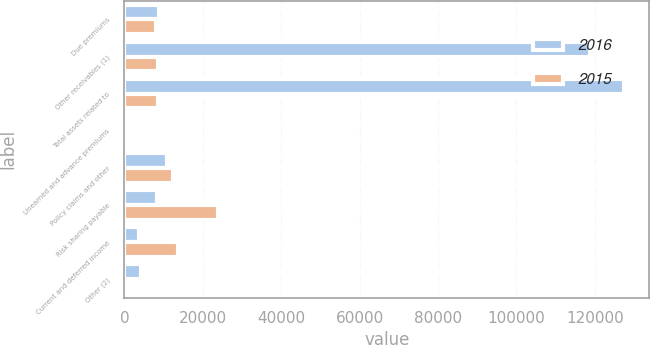Convert chart to OTSL. <chart><loc_0><loc_0><loc_500><loc_500><stacked_bar_chart><ecel><fcel>Due premiums<fcel>Other receivables (1)<fcel>Total assets related to<fcel>Unearned and advance premiums<fcel>Policy claims and other<fcel>Risk sharing payable<fcel>Current and deferred income<fcel>Other (2)<nl><fcel>2016<fcel>8840<fcel>118692<fcel>127532<fcel>67<fcel>10868<fcel>8374<fcel>3820<fcel>4295<nl><fcel>2015<fcel>8041<fcel>8607<fcel>8607<fcel>806<fcel>12309<fcel>23837<fcel>13604<fcel>479<nl></chart> 